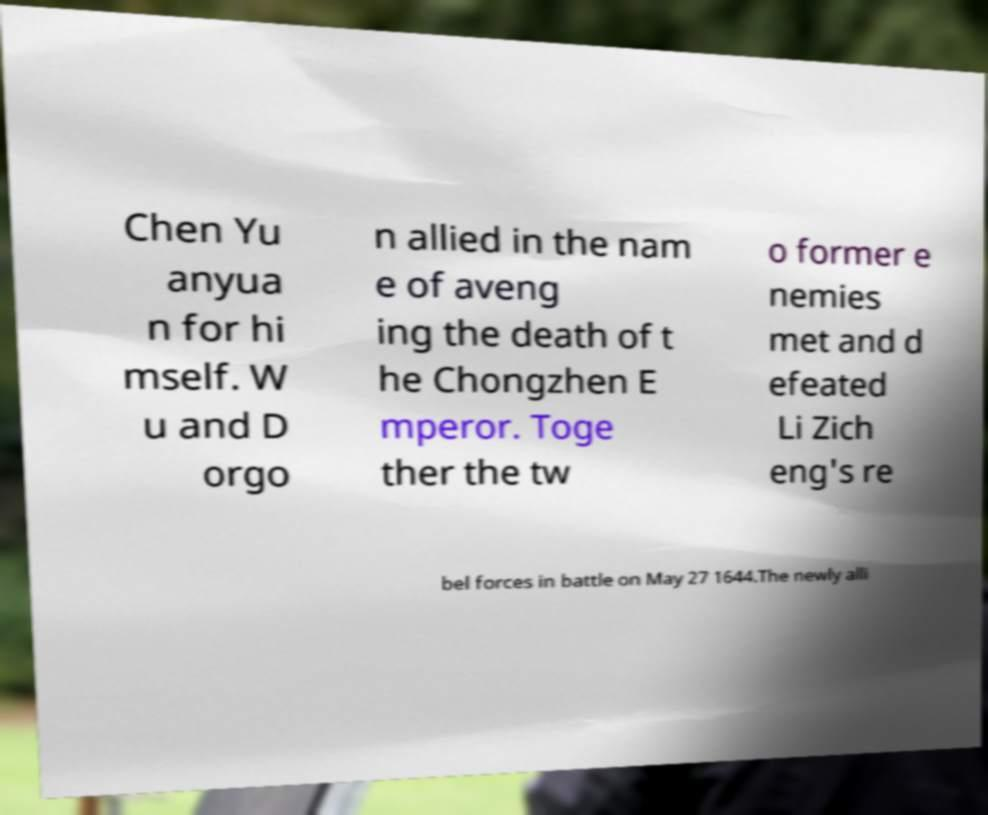Please read and relay the text visible in this image. What does it say? Chen Yu anyua n for hi mself. W u and D orgo n allied in the nam e of aveng ing the death of t he Chongzhen E mperor. Toge ther the tw o former e nemies met and d efeated Li Zich eng's re bel forces in battle on May 27 1644.The newly alli 